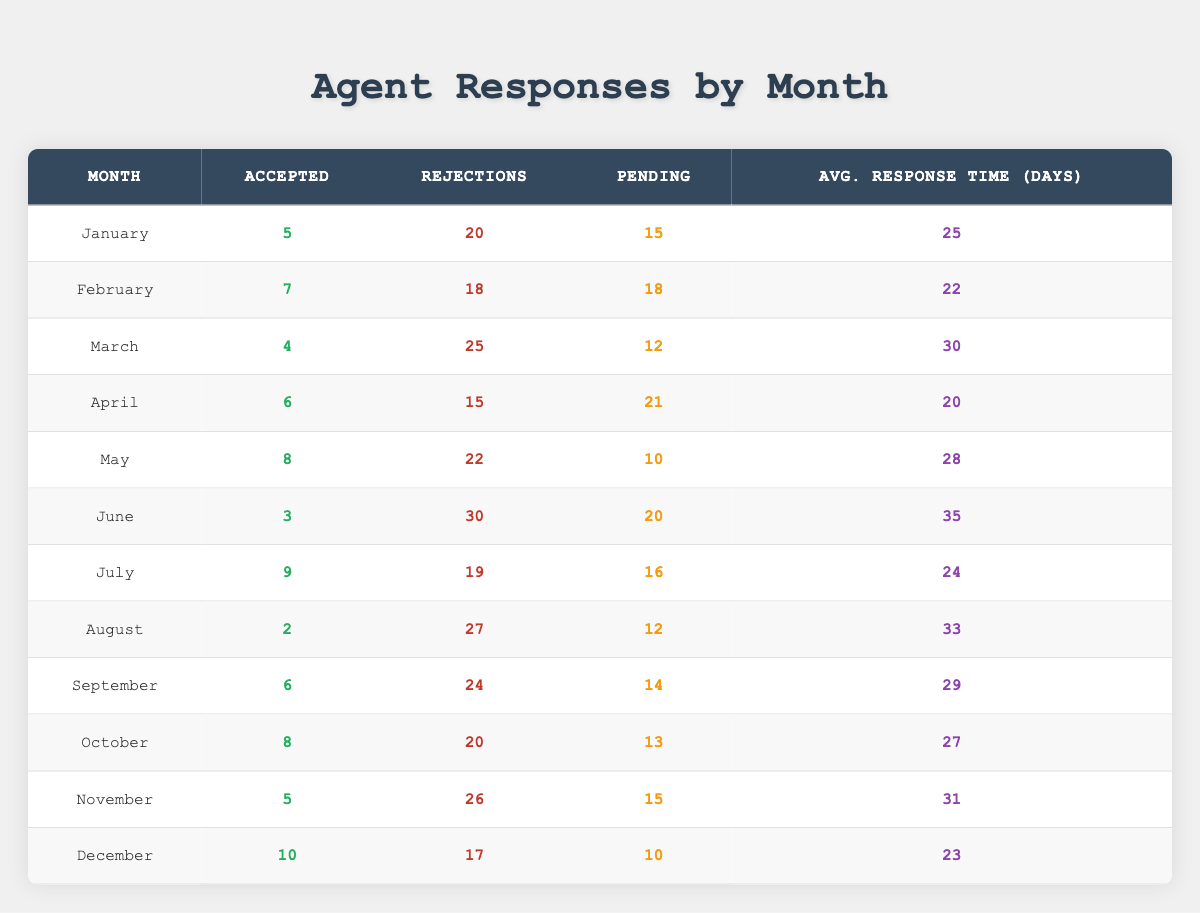What was the highest number of accepted submissions in a single month? By reviewing the "Accepted" column, I see that the highest value is 10, which occurred in December.
Answer: 10 How many total rejections were recorded in March? In March, the "Rejections" column shows a value of 25.
Answer: 25 What is the average response time for requests in June? The "Average Response Time (Days)" for June is listed as 35.
Answer: 35 Which month had the lowest number of accepted submissions? Checking the "Accepted" values, August has the lowest with 2 accepted submissions.
Answer: August What is the total number of pending submissions across all months? Adding the "Pending" values for each month: 15 + 18 + 12 + 21 + 10 + 20 + 16 + 12 + 14 + 13 + 15 + 10 =  156.
Answer: 156 Did any month have more than 30 rejections? Looking at the "Rejections" values, I see that June had 30 rejections, so the answer is yes.
Answer: Yes Which month had the best acceptance rate (accepted vs. total submissions)? To find the acceptance rate, I calculate the total submissions per month (Accepted + Rejections + Pending) and then divide accepted by total for each month. April has the best rate at 6 accepted out of 42 total submissions, which is approximately 14.29%.
Answer: April What is the median number of accepted submissions across the months? The accepted values are 2, 3, 4, 5, 5, 6, 7, 8, 8, 9, 10. The median is the average of the middle two values (6 and 7) which gives (6 + 7)/2 = 6.5.
Answer: 6.5 Was there a month where the rejections exceeded the accepted submissions by more than 15? Yes, both March (25 rejections - 4 accepted = 21 gap) and August (27 rejections - 2 accepted = 25 gap) exceed this criteria.
Answer: Yes In which month was the average response time the shortest? By comparing the "Average Response Time (Days)" across all months, April has the shortest average at 20 days.
Answer: April 